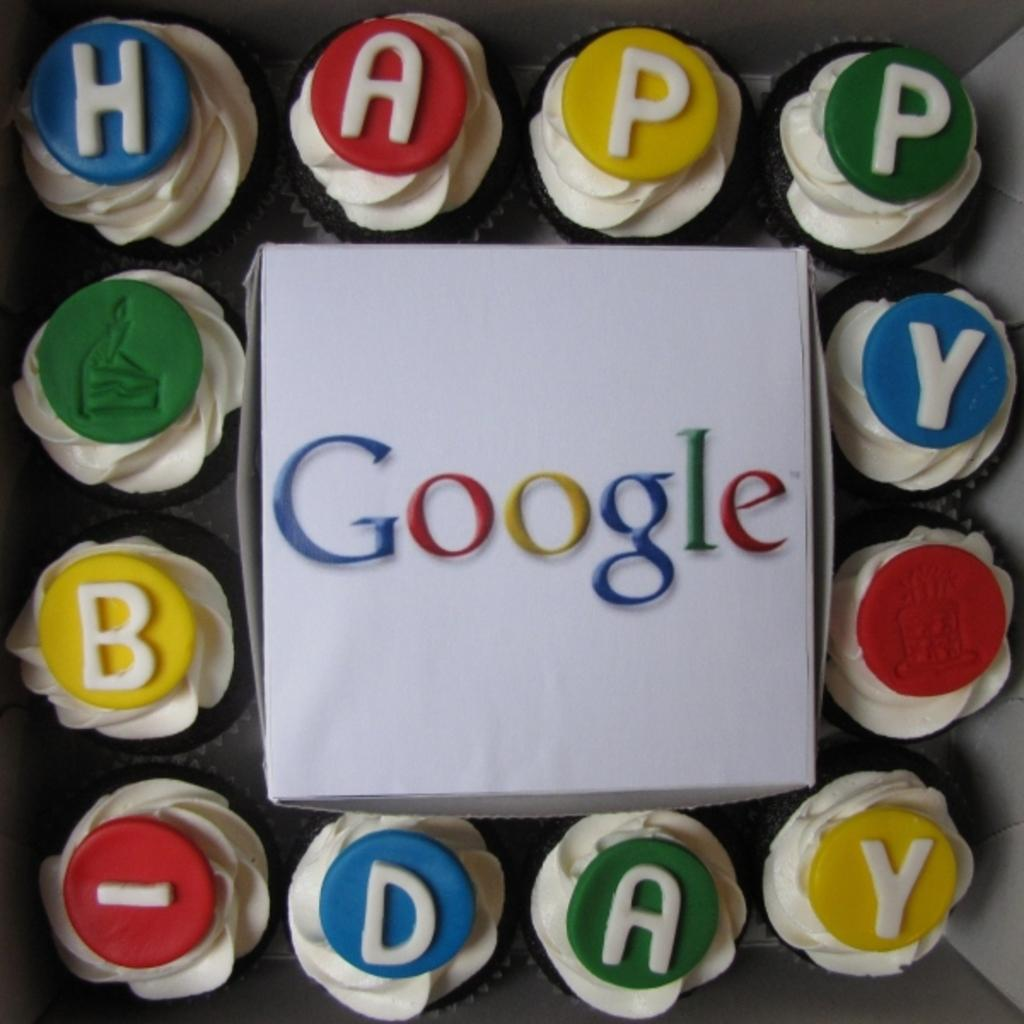What is the main object in the image? There is a box in the image. What is written on the box? The word "Google" is written on the box. What other items are visible around the box? There are cupcakes around the box. What message is conveyed by the words written on or near the box? The words "Happy Birthday" are written on or near the box, indicating a birthday celebration. What type of fuel is being used by the snail in the image? There is no snail present in the image, so it is not possible to determine what type of fuel it might be using. 